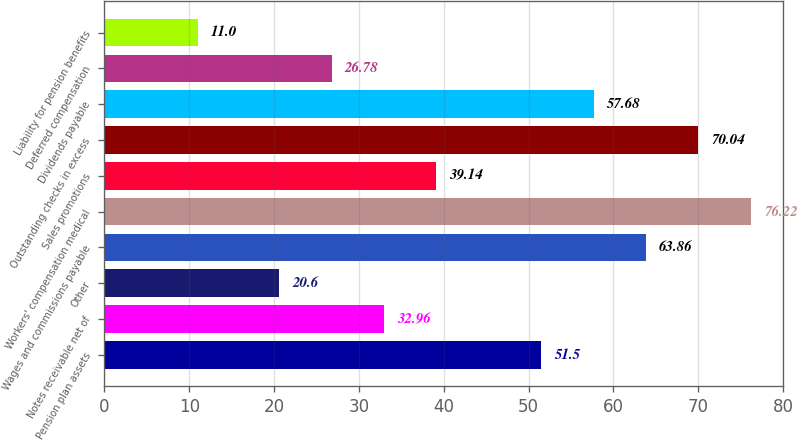Convert chart. <chart><loc_0><loc_0><loc_500><loc_500><bar_chart><fcel>Pension plan assets<fcel>Notes receivable net of<fcel>Other<fcel>Wages and commissions payable<fcel>Workers' compensation medical<fcel>Sales promotions<fcel>Outstanding checks in excess<fcel>Dividends payable<fcel>Deferred compensation<fcel>Liability for pension benefits<nl><fcel>51.5<fcel>32.96<fcel>20.6<fcel>63.86<fcel>76.22<fcel>39.14<fcel>70.04<fcel>57.68<fcel>26.78<fcel>11<nl></chart> 